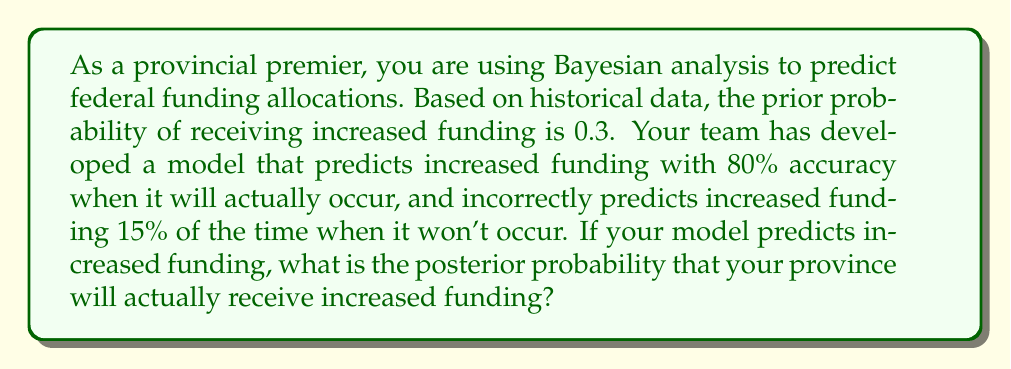What is the answer to this math problem? Let's approach this step-by-step using Bayes' theorem:

1) Define events:
   A: Actually receiving increased funding
   B: Model predicts increased funding

2) Given information:
   P(A) = 0.3 (prior probability)
   P(B|A) = 0.8 (true positive rate)
   P(B|not A) = 0.15 (false positive rate)

3) Bayes' theorem:
   $$P(A|B) = \frac{P(B|A) \cdot P(A)}{P(B)}$$

4) Calculate P(B) using the law of total probability:
   $$P(B) = P(B|A) \cdot P(A) + P(B|not A) \cdot P(not A)$$
   $$P(B) = 0.8 \cdot 0.3 + 0.15 \cdot 0.7 = 0.24 + 0.105 = 0.345$$

5) Now apply Bayes' theorem:
   $$P(A|B) = \frac{0.8 \cdot 0.3}{0.345} = \frac{0.24}{0.345} \approx 0.6957$$

6) Convert to a percentage:
   0.6957 * 100% ≈ 69.57%
Answer: 69.57% 